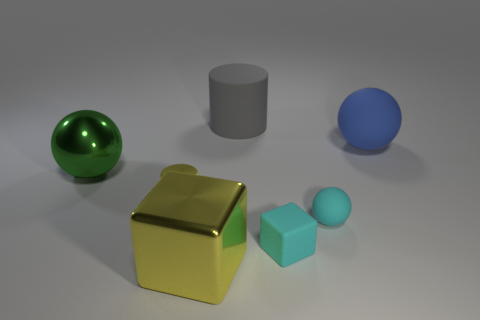Subtract all large spheres. How many spheres are left? 1 Add 2 large yellow metallic cubes. How many objects exist? 9 Subtract all cylinders. How many objects are left? 5 Subtract all big blue balls. Subtract all large spheres. How many objects are left? 4 Add 7 big yellow metallic things. How many big yellow metallic things are left? 8 Add 5 yellow metal things. How many yellow metal things exist? 7 Subtract 0 purple balls. How many objects are left? 7 